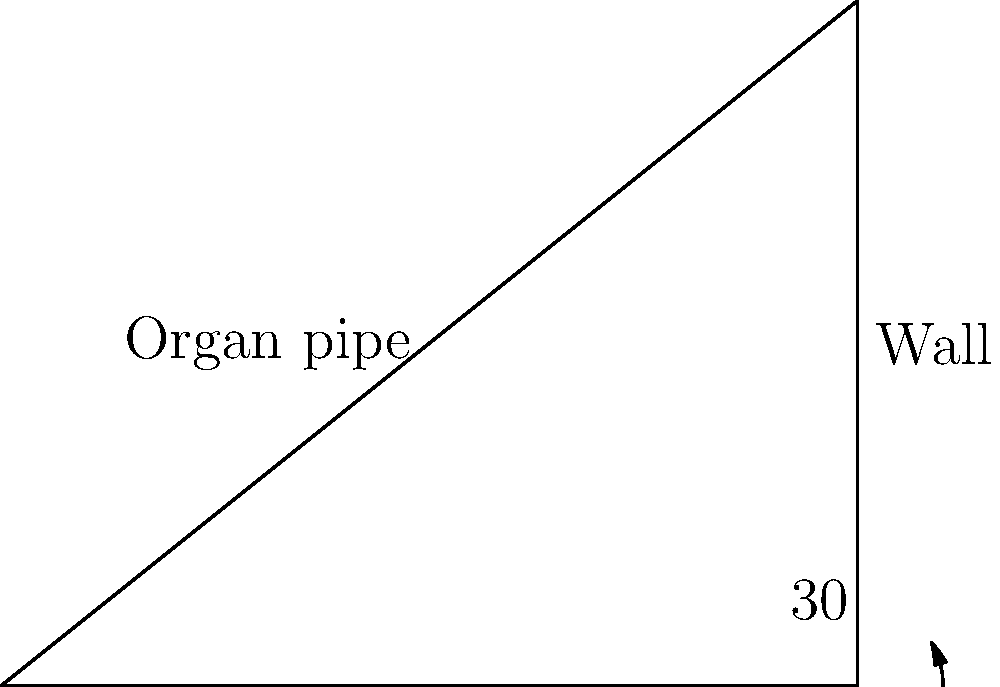In a traditional church setting, an organ pipe is positioned against a wall at an angle of inclination. If the optimal angle for sound production is 30° from the vertical, what is the angle between the organ pipe and the wall? To solve this problem, let's follow these steps:

1. Recognize that the organ pipe forms a right-angled triangle with the wall and the floor.

2. The angle given (30°) is between the organ pipe and the vertical wall. This means it's complementary to the angle we're looking for.

3. In a right-angled triangle, the sum of all angles is 90°.

4. We know one angle is 90° (the right angle where the wall meets the floor), and another is 30° (between the pipe and the wall).

5. To find the angle between the pipe and the wall, we subtract the known angles from 180°:

   $180° - 90° - 30° = 60°$

6. Therefore, the angle between the organ pipe and the wall is 60°.

This 60° angle ensures that the organ pipe is positioned at the optimal 30° from the vertical, allowing for the best sound production in the traditional church setting.
Answer: 60° 